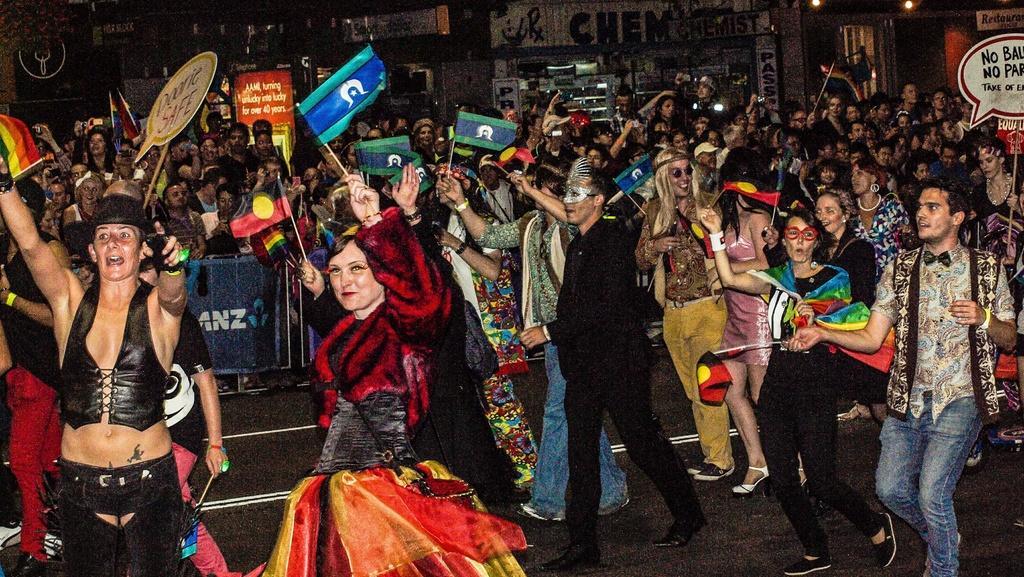Could you give a brief overview of what you see in this image? In the center of the image we can see a few people are standing and they are smiling, which we can see on their faces. And they are in different costumes. And we can see a few people are holding flags and banners. In the background, we can see buildings, banners, few people are standing, few people are holding some objects and a few other objects. 